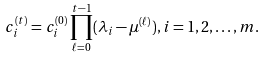<formula> <loc_0><loc_0><loc_500><loc_500>c _ { i } ^ { ( t ) } = c _ { i } ^ { ( 0 ) } \prod _ { \ell = 0 } ^ { t - 1 } ( \lambda _ { i } - \mu ^ { ( \ell ) } ) , i = 1 , 2 , \dots , m .</formula> 